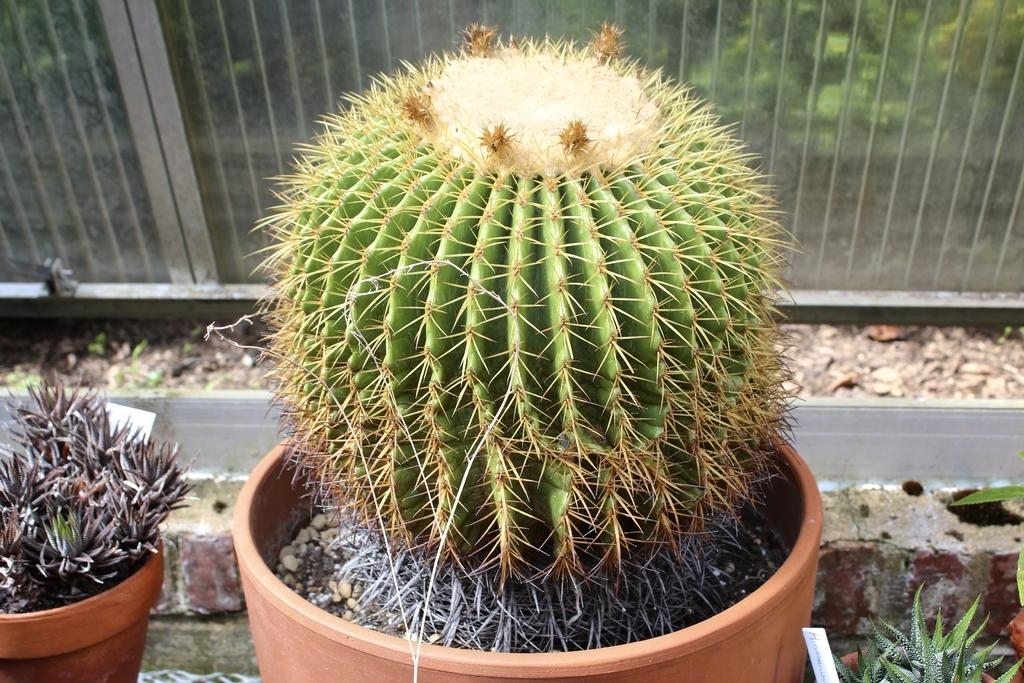What is located in the foreground of the picture? There are plants in the foreground of the picture. What can be seen in the background of the picture? There is a railing in the background of the picture. What type of environment is visible behind the railing? There is greenery visible behind the railing. What type of treatment is being administered in the picture? There is no treatment being administered in the picture; it features plants in the foreground and a railing with greenery in the background. What kind of record can be seen in the picture? There is no record present in the picture. 